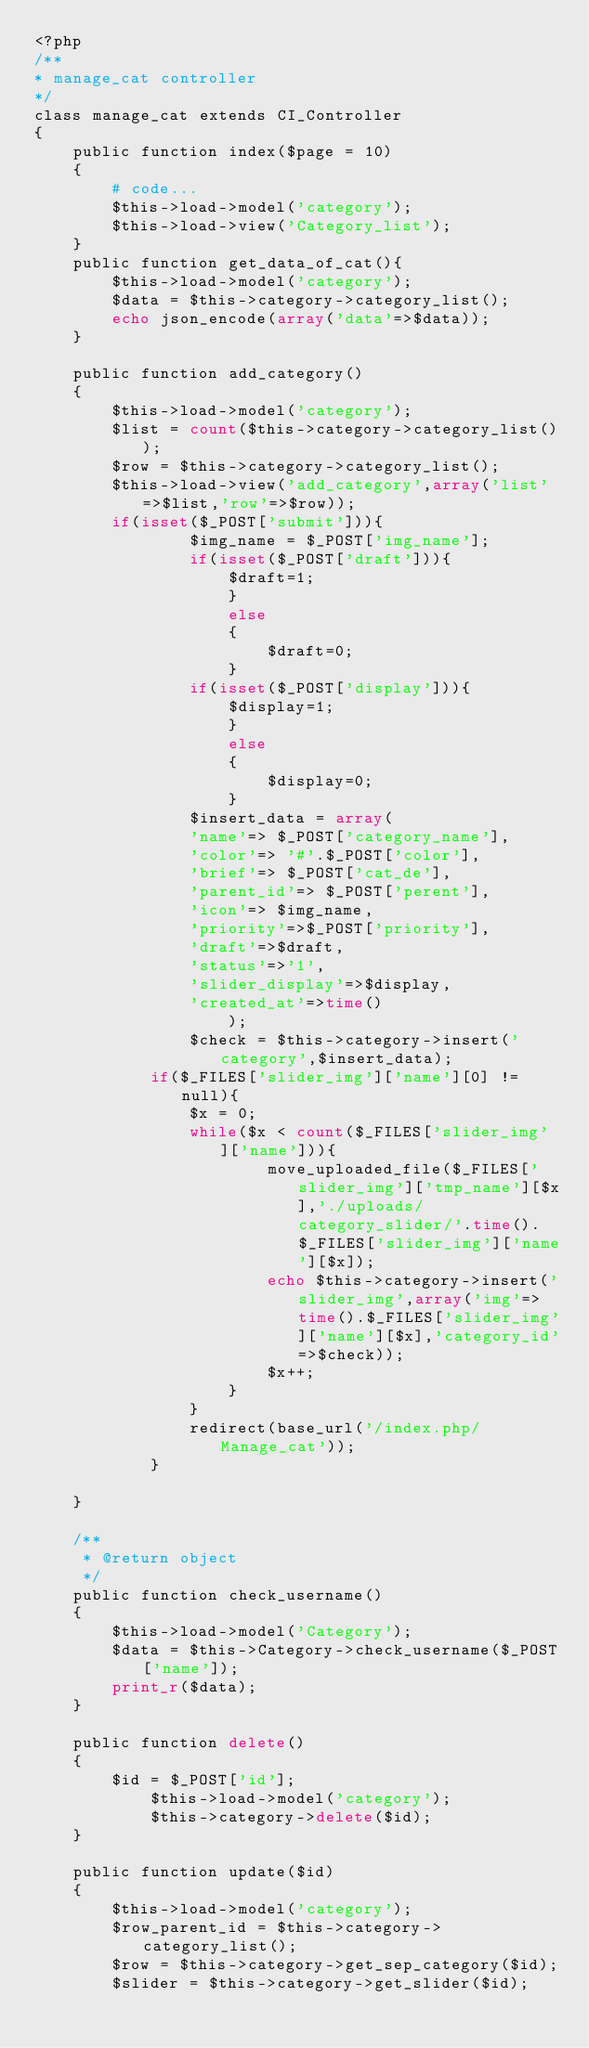Convert code to text. <code><loc_0><loc_0><loc_500><loc_500><_PHP_><?php
/**
* manage_cat controller
*/
class manage_cat extends CI_Controller
{
	public function index($page = 10)
	{
		# code...
        $this->load->model('category');
        $this->load->view('Category_list');
	}
	public function get_data_of_cat(){
	    $this->load->model('category');
        $data = $this->category->category_list();
        echo json_encode(array('data'=>$data));
    }
	
	public function add_category()
	{
		$this->load->model('category');
		$list = count($this->category->category_list());
		$row = $this->category->category_list();
		$this->load->view('add_category',array('list'=>$list,'row'=>$row));
		if(isset($_POST['submit'])){
				$img_name = $_POST['img_name'];
				if(isset($_POST['draft'])){
					$draft=1;
					}
					else
					{
						$draft=0;
					}
				if(isset($_POST['display'])){
					$display=1;
					}
					else
					{
						$display=0;
					}
				$insert_data = array(
				'name'=> $_POST['category_name'],
				'color'=> '#'.$_POST['color'],
				'brief'=> $_POST['cat_de'],
				'parent_id'=> $_POST['perent'],
				'icon'=> $img_name,
				'priority'=>$_POST['priority'],
				'draft'=>$draft,
				'status'=>'1',
				'slider_display'=>$display,
				'created_at'=>time()
					);
				$check = $this->category->insert('category',$insert_data);
            if($_FILES['slider_img']['name'][0] != null){
                $x = 0;
                while($x < count($_FILES['slider_img']['name'])){
                        move_uploaded_file($_FILES['slider_img']['tmp_name'][$x],'./uploads/category_slider/'.time().$_FILES['slider_img']['name'][$x]);
                        echo $this->category->insert('slider_img',array('img'=>time().$_FILES['slider_img']['name'][$x],'category_id'=>$check));
                        $x++;
                    }
                }
                redirect(base_url('/index.php/Manage_cat'));
	        }
	
	}

    /**
     * @return object
     */
    public function check_username()
    {
        $this->load->model('Category');
        $data = $this->Category->check_username($_POST['name']);
        print_r($data);
    }

    public function delete()
    {
        $id = $_POST['id'];
            $this->load->model('category');
            $this->category->delete($id);
    }

    public function update($id)
    {
        $this->load->model('category');
        $row_parent_id = $this->category->category_list();
        $row = $this->category->get_sep_category($id);
        $slider = $this->category->get_slider($id);</code> 